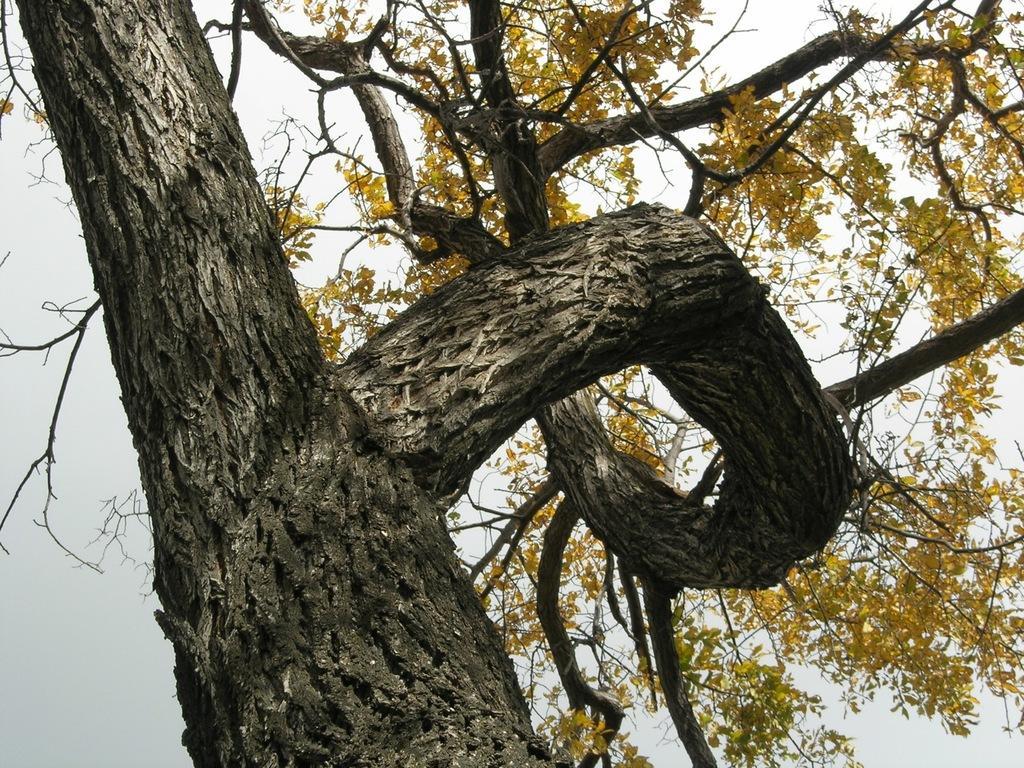Can you describe this image briefly? In the foreground of this image, there is a tree. In the background, there is the sky. 